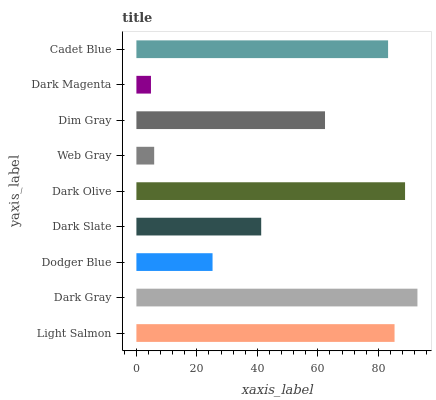Is Dark Magenta the minimum?
Answer yes or no. Yes. Is Dark Gray the maximum?
Answer yes or no. Yes. Is Dodger Blue the minimum?
Answer yes or no. No. Is Dodger Blue the maximum?
Answer yes or no. No. Is Dark Gray greater than Dodger Blue?
Answer yes or no. Yes. Is Dodger Blue less than Dark Gray?
Answer yes or no. Yes. Is Dodger Blue greater than Dark Gray?
Answer yes or no. No. Is Dark Gray less than Dodger Blue?
Answer yes or no. No. Is Dim Gray the high median?
Answer yes or no. Yes. Is Dim Gray the low median?
Answer yes or no. Yes. Is Dodger Blue the high median?
Answer yes or no. No. Is Web Gray the low median?
Answer yes or no. No. 